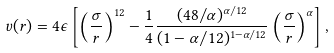Convert formula to latex. <formula><loc_0><loc_0><loc_500><loc_500>v ( r ) = 4 \epsilon \left [ \left ( \frac { \sigma } { r } \right ) ^ { 1 2 } - \frac { 1 } { 4 } \frac { ( 4 8 / \alpha ) ^ { \alpha / 1 2 } } { ( 1 - \alpha / 1 2 ) ^ { 1 - \alpha / 1 2 } } \left ( \frac { \sigma } { r } \right ) ^ { \alpha } \right ] ,</formula> 